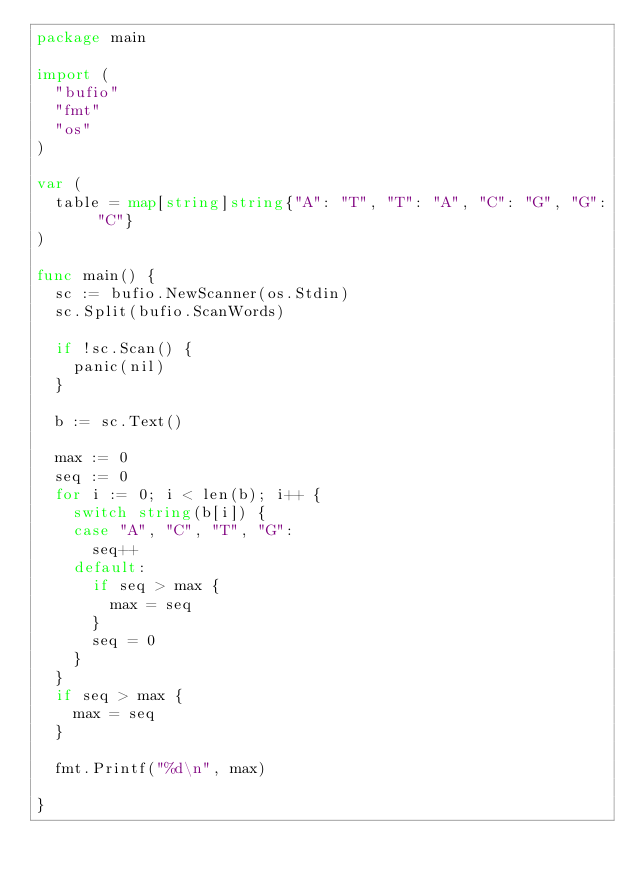<code> <loc_0><loc_0><loc_500><loc_500><_Go_>package main

import (
	"bufio"
	"fmt"
	"os"
)

var (
	table = map[string]string{"A": "T", "T": "A", "C": "G", "G": "C"}
)

func main() {
	sc := bufio.NewScanner(os.Stdin)
	sc.Split(bufio.ScanWords)

	if !sc.Scan() {
		panic(nil)
	}

	b := sc.Text()

	max := 0
	seq := 0
	for i := 0; i < len(b); i++ {
		switch string(b[i]) {
		case "A", "C", "T", "G":
			seq++
		default:
			if seq > max {
				max = seq
			}
			seq = 0
		}
	}
	if seq > max {
		max = seq
	}

	fmt.Printf("%d\n", max)

}
</code> 